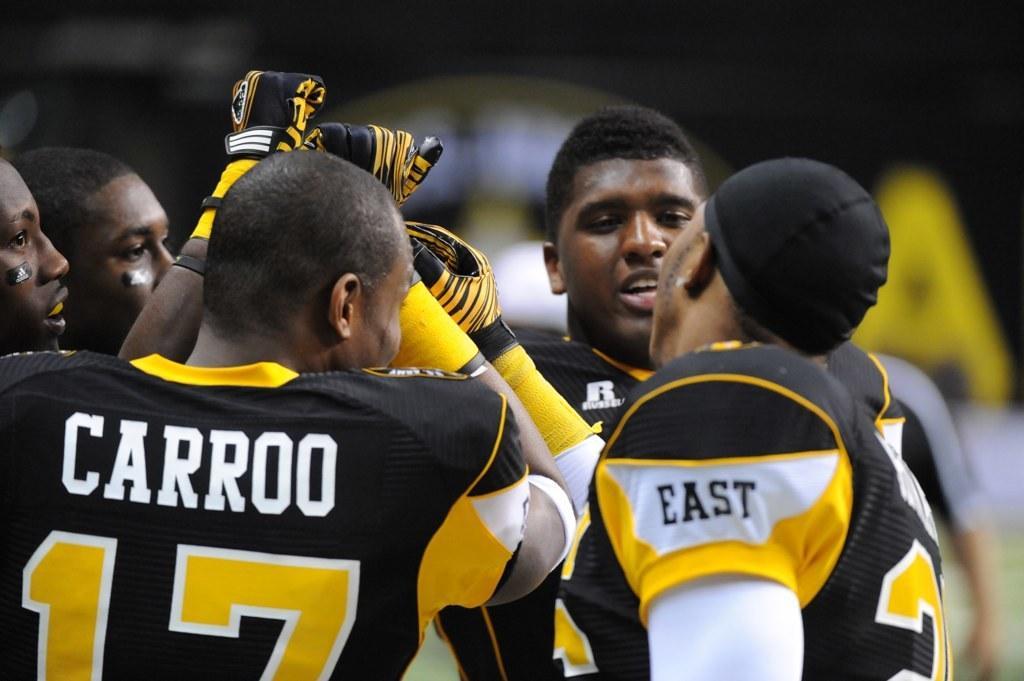Could you give a brief overview of what you see in this image? In this picture we can observe rugby players, wearing black and yellow color dresses. One of them was wearing a cap on his head. All of them were men. In the background it is completely blur. 